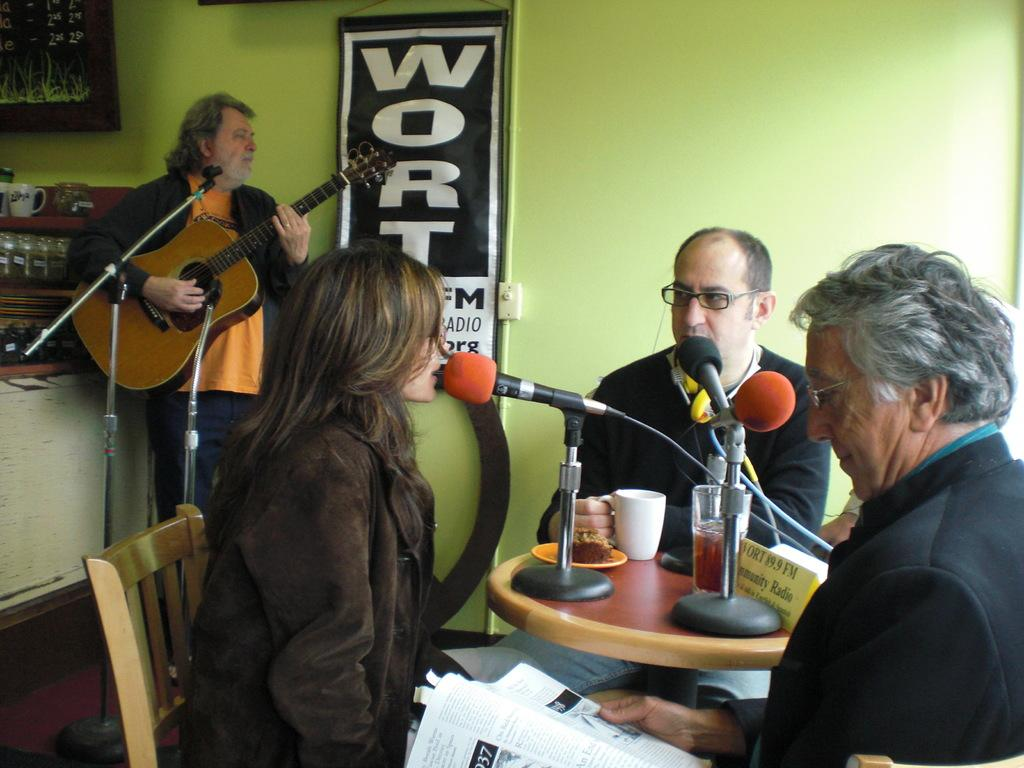What is happening in the image? There are people in the image performing different activities. Can you describe the person in the bottom right corner of the image? The person in the bottom right corner is reading. What else can be observed about the people in the image? The people are performing different activities, but we cannot determine the specific activities from the provided facts. What type of wilderness can be seen in the background of the image? There is no wilderness present in the image; it features people performing different activities. What is the person in the bottom right corner writing about? The person in the bottom right corner is reading, not writing, so we cannot determine what they might be writing about. 